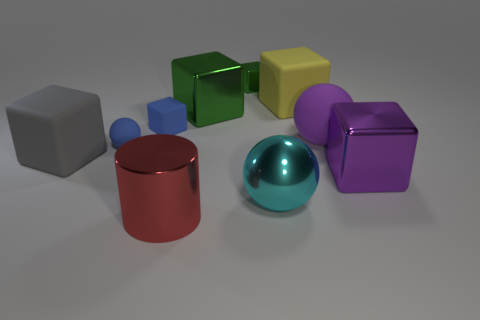How could these objects be used to explain geometric shapes and properties? These objects serve as perfect examples for a lesson in geometry. They include various geometric shapes like spheres, cubes, and a cylinder, each with distinct properties such as edges, vertices, and faces. Observing these objects can help illustrate concepts like volume, surface area, and the differences between 2D and 3D shapes. 